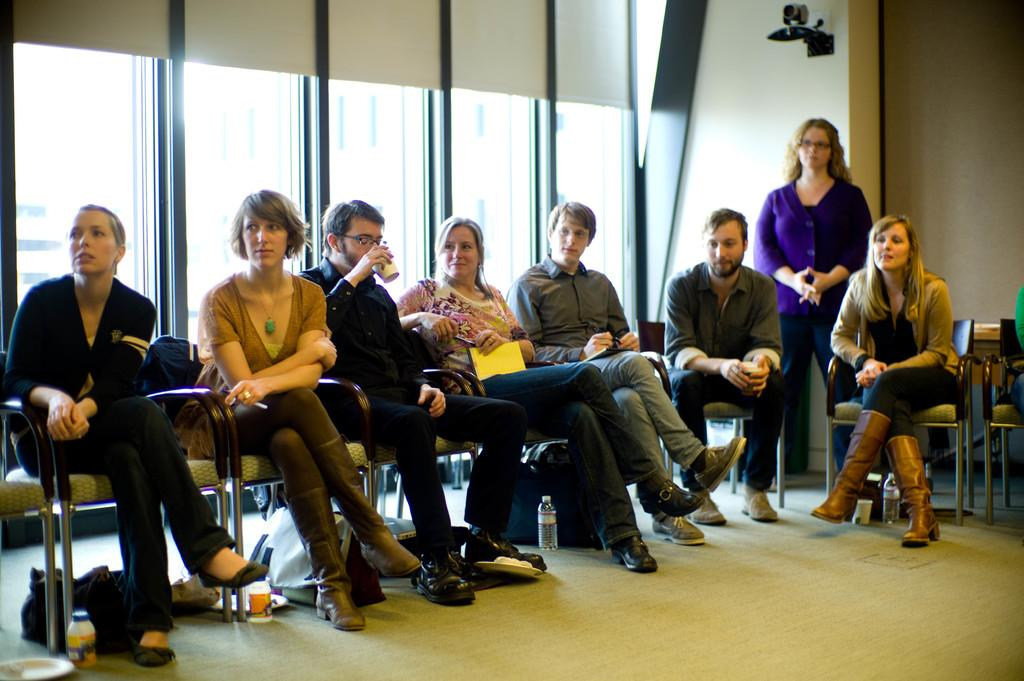What are the people in the image doing? The people in the image are sitting on chairs and holding cups. Can you describe the person who is not sitting in the image? There is a person standing in the image. What is the background of the image made of? There is a wall in the image, which is likely the background. Are there any transparent elements in the image? Yes, there are glass windows in the image. What type of yam is being used as a fork in the image? There is no yam or fork present in the image. How many buckets are visible in the image? There are no buckets visible in the image. 